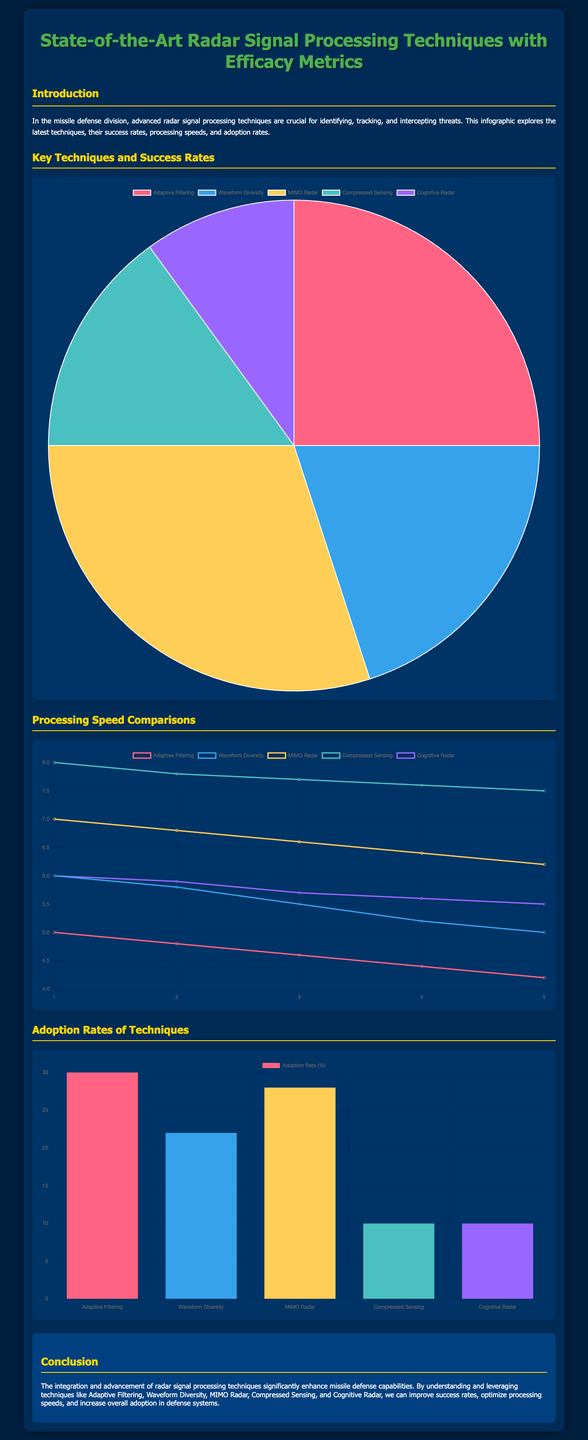What is the success rate of MIMO Radar? The success rate of MIMO Radar is represented in the pie chart as 30%.
Answer: 30% Which technique has the lowest adoption rate? The adoption rates bar chart indicates that Compressed Sensing and Cognitive Radar both have the lowest adoption rate of 10%.
Answer: 10% What color represents Waveform Diversity in the success rates chart? Waveform Diversity is represented by the color blue in the pie chart.
Answer: Blue What was the processing speed (in ms) for Waveform Diversity after 5 months? The line chart shows that the processing speed for Waveform Diversity after 5 months is 5 ms.
Answer: 5 ms Which technique has the highest increase in processing speed over time? The line chart shows that Compressed Sensing consistently has the highest speed, starting at 8 ms and lowering gradually, but remains the highest.
Answer: Compressed Sensing What is the primary purpose mentioned in the document? The document emphasizes the importance of advanced radar signal processing techniques for identifying, tracking, and intercepting threats.
Answer: Identifying, tracking, intercepting threats Which radar technique has an adoption rate of 30%? The bar chart shows that Adaptive Filtering has an adoption rate of 30%.
Answer: Adaptive Filtering How many radar signal processing techniques are listed in the document? The document lists five radar signal processing techniques, as identified in the charts.
Answer: Five What is the time frame represented in the processing speed comparison? The time frame represented is over a period of five months, as shown in the x-axis labels of the line chart.
Answer: Five months 